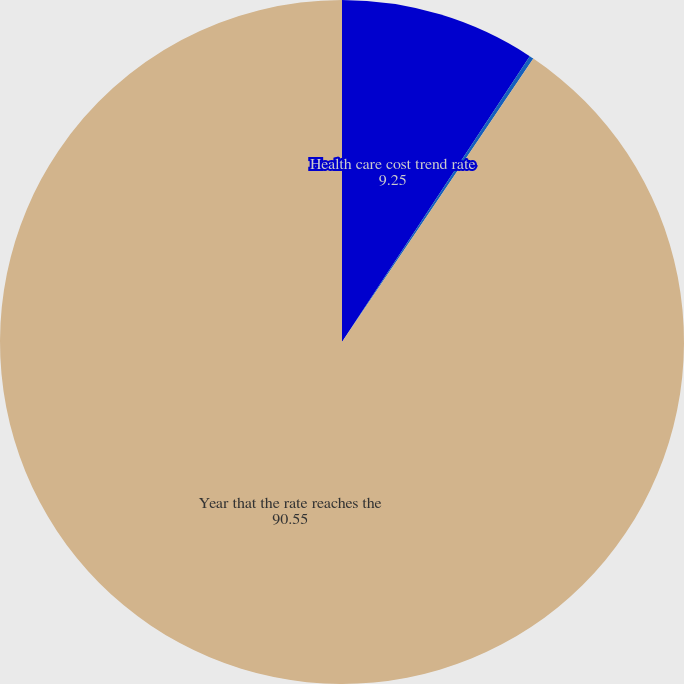<chart> <loc_0><loc_0><loc_500><loc_500><pie_chart><fcel>Health care cost trend rate<fcel>Rate to which the cost trend<fcel>Year that the rate reaches the<nl><fcel>9.25%<fcel>0.2%<fcel>90.55%<nl></chart> 